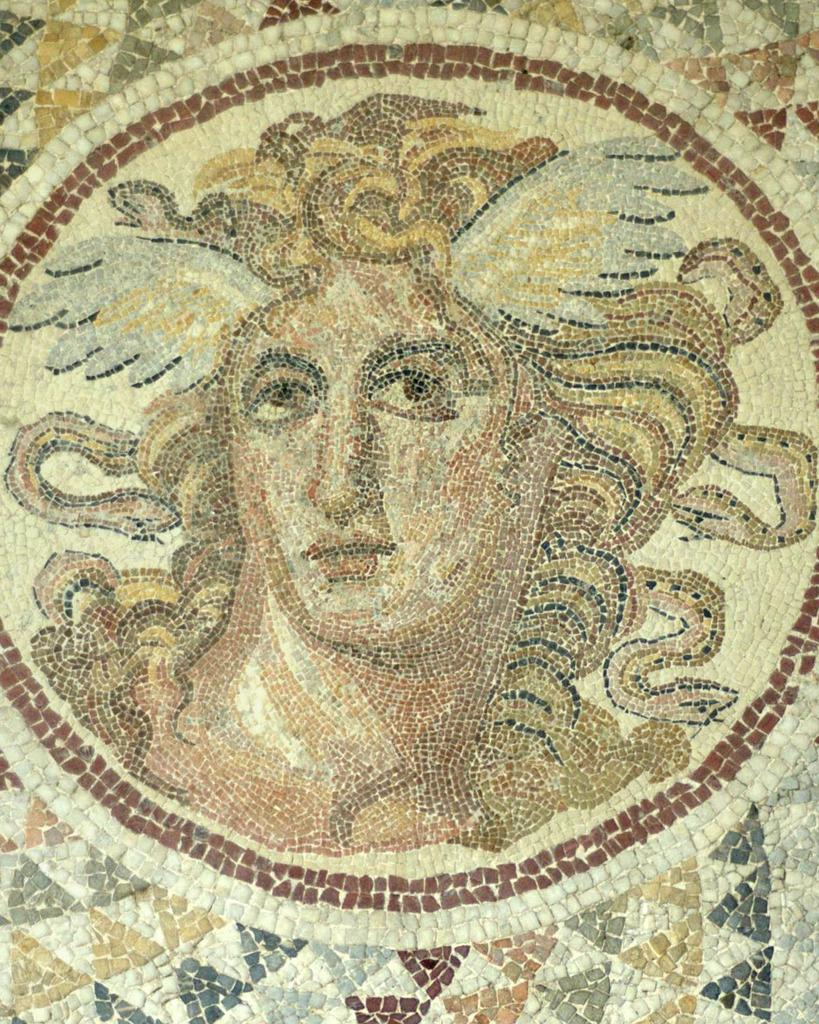What is the main subject of the picture? The main subject of the picture is an image of a person. How is the image of the person created? The image is made up of different pieces of tiles. What type of yam is being used as a decoration at the event in the image? There is no yam or event present in the image; it features an image of a person created with different pieces of tiles. What punishment is being depicted in the image? There is no punishment being depicted in the image; it features an image of a person created with different pieces of tiles. 